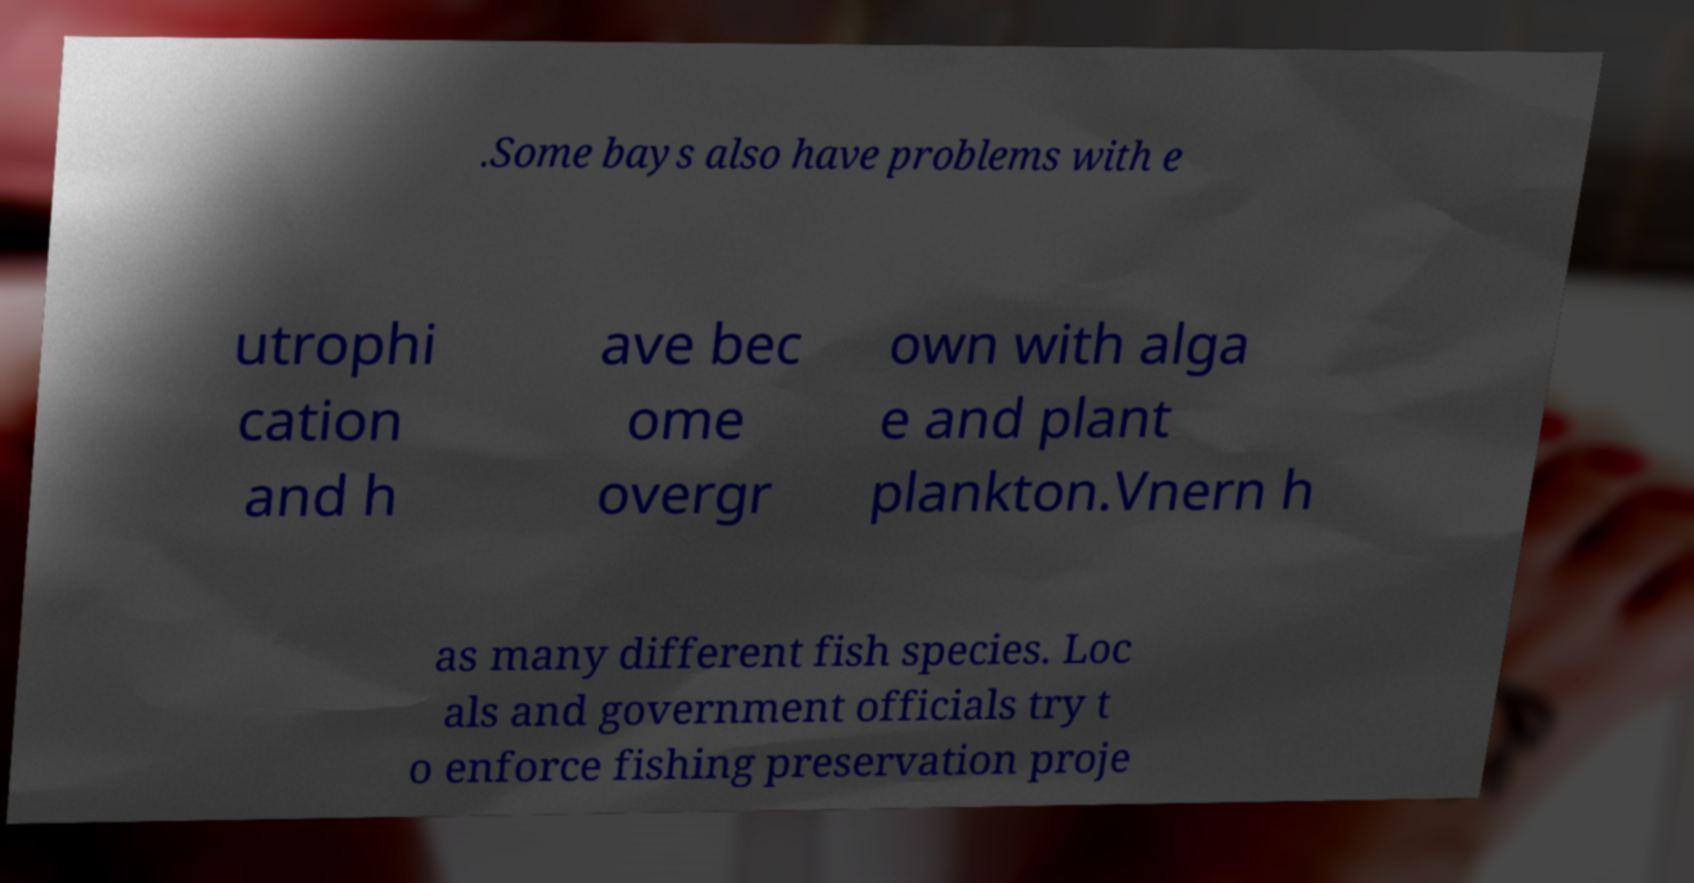What messages or text are displayed in this image? I need them in a readable, typed format. .Some bays also have problems with e utrophi cation and h ave bec ome overgr own with alga e and plant plankton.Vnern h as many different fish species. Loc als and government officials try t o enforce fishing preservation proje 